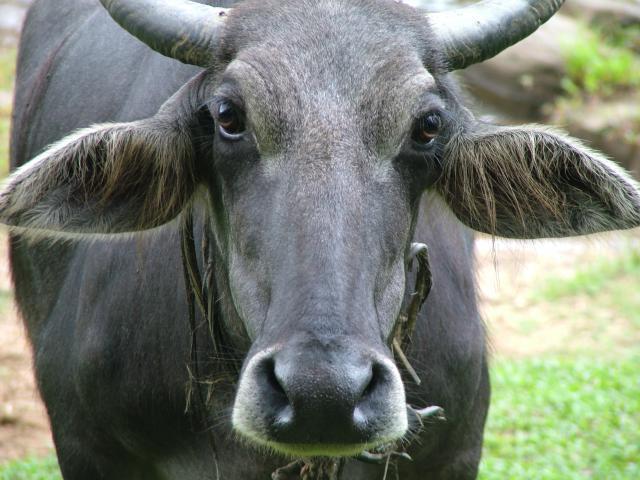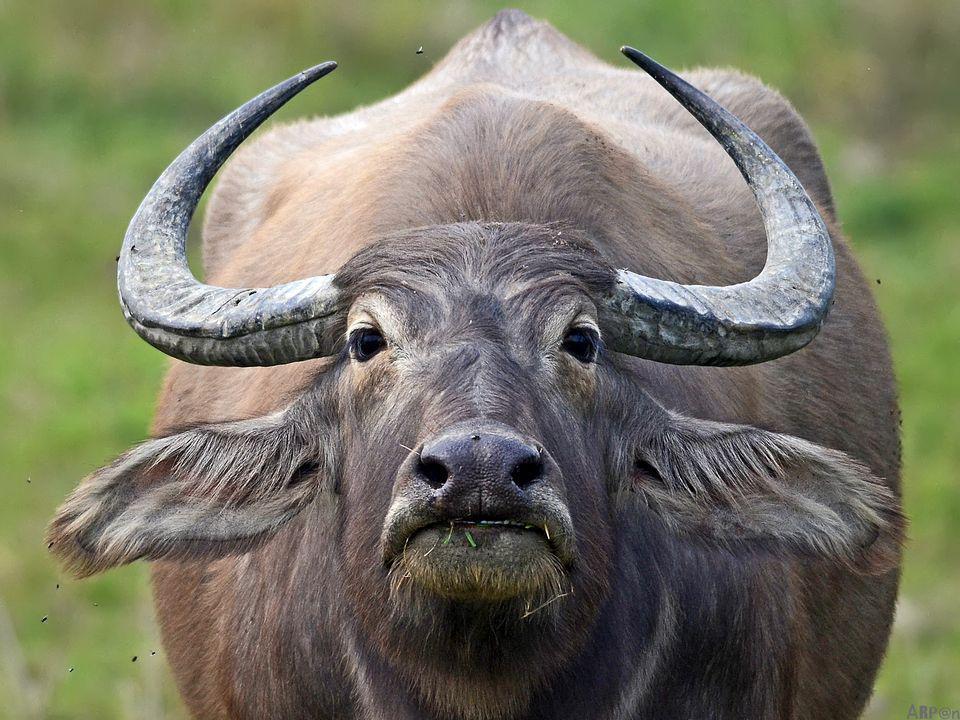The first image is the image on the left, the second image is the image on the right. Given the left and right images, does the statement "Every animal has horns and none has a bird on its head." hold true? Answer yes or no. Yes. The first image is the image on the left, the second image is the image on the right. For the images shown, is this caption "The animal in the image on the left is turned directly toward the camera" true? Answer yes or no. Yes. 